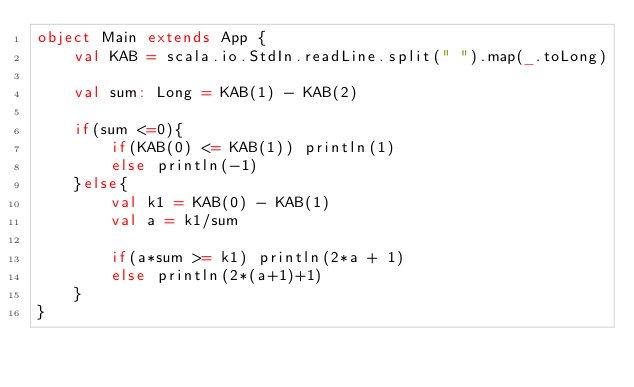<code> <loc_0><loc_0><loc_500><loc_500><_Scala_>object Main extends App {
	val KAB = scala.io.StdIn.readLine.split(" ").map(_.toLong)

	val sum: Long = KAB(1) - KAB(2)

	if(sum <=0){
		if(KAB(0) <= KAB(1)) println(1)
		else println(-1)
	}else{
		val k1 = KAB(0) - KAB(1)
		val a = k1/sum

		if(a*sum >= k1) println(2*a + 1)
		else println(2*(a+1)+1)
	}
}</code> 